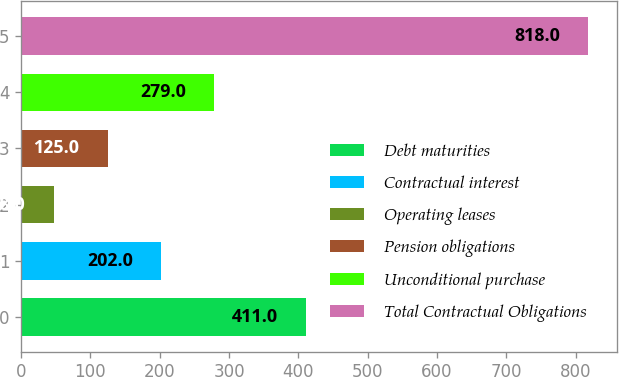<chart> <loc_0><loc_0><loc_500><loc_500><bar_chart><fcel>Debt maturities<fcel>Contractual interest<fcel>Operating leases<fcel>Pension obligations<fcel>Unconditional purchase<fcel>Total Contractual Obligations<nl><fcel>411<fcel>202<fcel>48<fcel>125<fcel>279<fcel>818<nl></chart> 